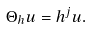<formula> <loc_0><loc_0><loc_500><loc_500>\Theta _ { h } u = h ^ { j } u .</formula> 